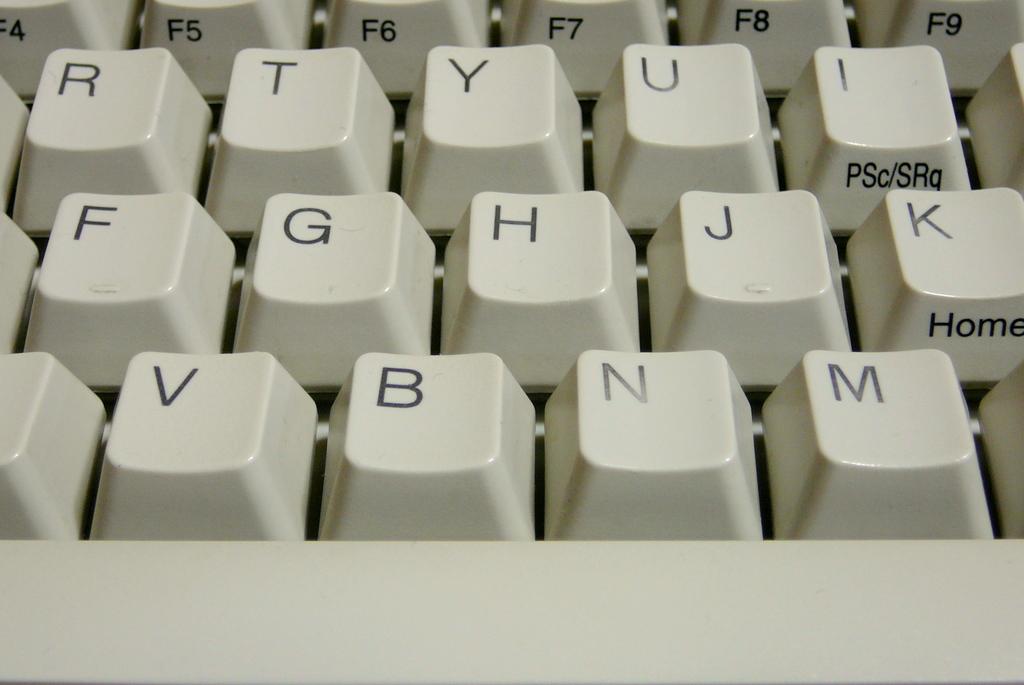Which key is also the home key?
Give a very brief answer. K. What letter is to the left of b?
Provide a succinct answer. V. 